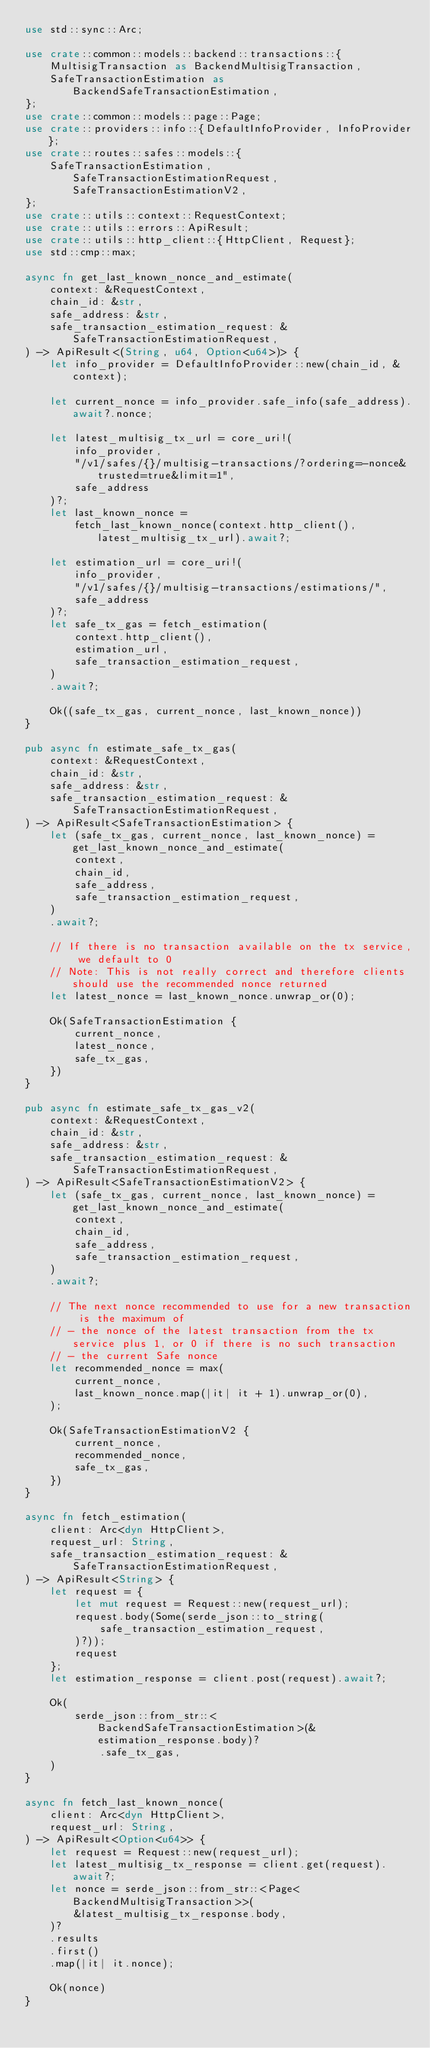<code> <loc_0><loc_0><loc_500><loc_500><_Rust_>use std::sync::Arc;

use crate::common::models::backend::transactions::{
    MultisigTransaction as BackendMultisigTransaction,
    SafeTransactionEstimation as BackendSafeTransactionEstimation,
};
use crate::common::models::page::Page;
use crate::providers::info::{DefaultInfoProvider, InfoProvider};
use crate::routes::safes::models::{
    SafeTransactionEstimation, SafeTransactionEstimationRequest, SafeTransactionEstimationV2,
};
use crate::utils::context::RequestContext;
use crate::utils::errors::ApiResult;
use crate::utils::http_client::{HttpClient, Request};
use std::cmp::max;

async fn get_last_known_nonce_and_estimate(
    context: &RequestContext,
    chain_id: &str,
    safe_address: &str,
    safe_transaction_estimation_request: &SafeTransactionEstimationRequest,
) -> ApiResult<(String, u64, Option<u64>)> {
    let info_provider = DefaultInfoProvider::new(chain_id, &context);

    let current_nonce = info_provider.safe_info(safe_address).await?.nonce;

    let latest_multisig_tx_url = core_uri!(
        info_provider,
        "/v1/safes/{}/multisig-transactions/?ordering=-nonce&trusted=true&limit=1",
        safe_address
    )?;
    let last_known_nonce =
        fetch_last_known_nonce(context.http_client(), latest_multisig_tx_url).await?;

    let estimation_url = core_uri!(
        info_provider,
        "/v1/safes/{}/multisig-transactions/estimations/",
        safe_address
    )?;
    let safe_tx_gas = fetch_estimation(
        context.http_client(),
        estimation_url,
        safe_transaction_estimation_request,
    )
    .await?;

    Ok((safe_tx_gas, current_nonce, last_known_nonce))
}

pub async fn estimate_safe_tx_gas(
    context: &RequestContext,
    chain_id: &str,
    safe_address: &str,
    safe_transaction_estimation_request: &SafeTransactionEstimationRequest,
) -> ApiResult<SafeTransactionEstimation> {
    let (safe_tx_gas, current_nonce, last_known_nonce) = get_last_known_nonce_and_estimate(
        context,
        chain_id,
        safe_address,
        safe_transaction_estimation_request,
    )
    .await?;

    // If there is no transaction available on the tx service, we default to 0
    // Note: This is not really correct and therefore clients should use the recommended nonce returned
    let latest_nonce = last_known_nonce.unwrap_or(0);

    Ok(SafeTransactionEstimation {
        current_nonce,
        latest_nonce,
        safe_tx_gas,
    })
}

pub async fn estimate_safe_tx_gas_v2(
    context: &RequestContext,
    chain_id: &str,
    safe_address: &str,
    safe_transaction_estimation_request: &SafeTransactionEstimationRequest,
) -> ApiResult<SafeTransactionEstimationV2> {
    let (safe_tx_gas, current_nonce, last_known_nonce) = get_last_known_nonce_and_estimate(
        context,
        chain_id,
        safe_address,
        safe_transaction_estimation_request,
    )
    .await?;

    // The next nonce recommended to use for a new transaction is the maximum of
    // - the nonce of the latest transaction from the tx service plus 1, or 0 if there is no such transaction
    // - the current Safe nonce
    let recommended_nonce = max(
        current_nonce,
        last_known_nonce.map(|it| it + 1).unwrap_or(0),
    );

    Ok(SafeTransactionEstimationV2 {
        current_nonce,
        recommended_nonce,
        safe_tx_gas,
    })
}

async fn fetch_estimation(
    client: Arc<dyn HttpClient>,
    request_url: String,
    safe_transaction_estimation_request: &SafeTransactionEstimationRequest,
) -> ApiResult<String> {
    let request = {
        let mut request = Request::new(request_url);
        request.body(Some(serde_json::to_string(
            safe_transaction_estimation_request,
        )?));
        request
    };
    let estimation_response = client.post(request).await?;

    Ok(
        serde_json::from_str::<BackendSafeTransactionEstimation>(&estimation_response.body)?
            .safe_tx_gas,
    )
}

async fn fetch_last_known_nonce(
    client: Arc<dyn HttpClient>,
    request_url: String,
) -> ApiResult<Option<u64>> {
    let request = Request::new(request_url);
    let latest_multisig_tx_response = client.get(request).await?;
    let nonce = serde_json::from_str::<Page<BackendMultisigTransaction>>(
        &latest_multisig_tx_response.body,
    )?
    .results
    .first()
    .map(|it| it.nonce);

    Ok(nonce)
}
</code> 